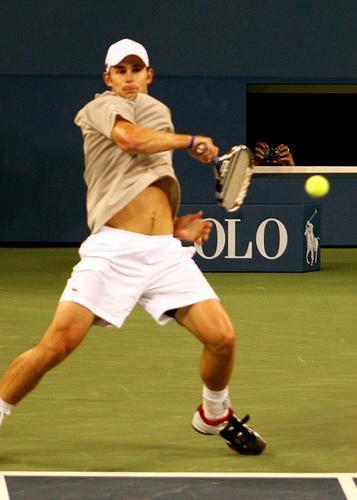How many elephants are in the water?
Give a very brief answer. 0. 